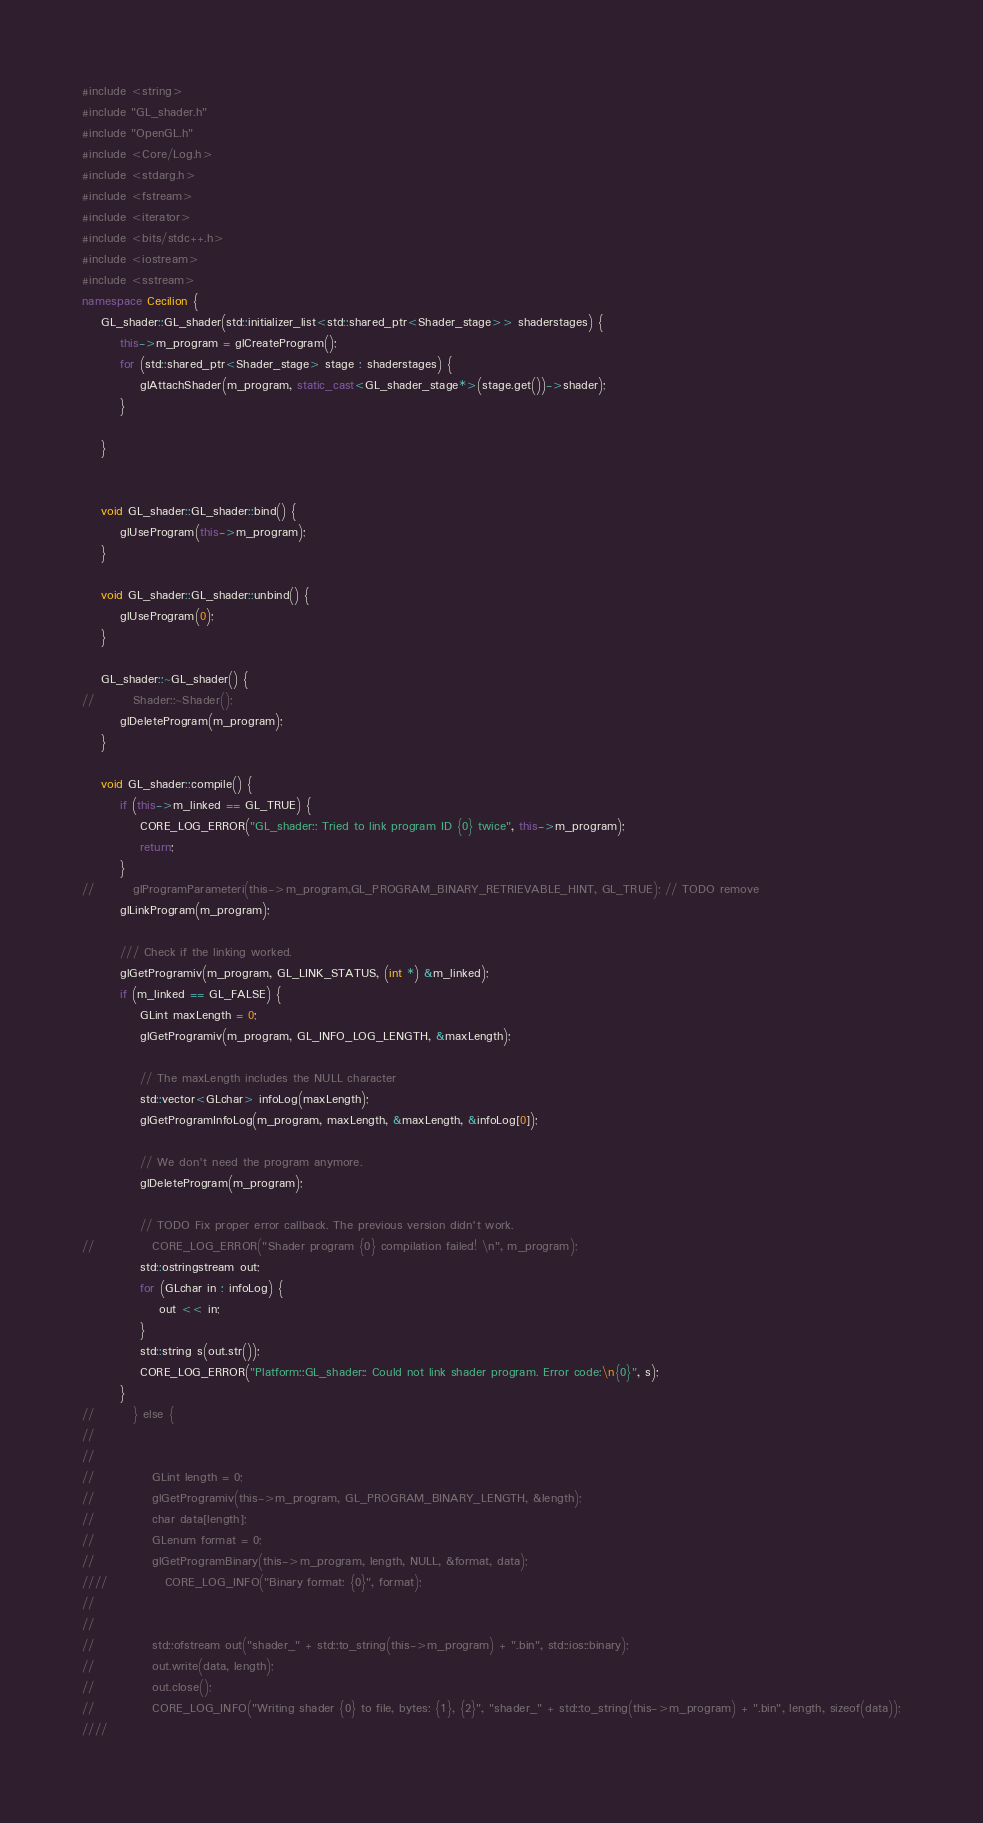<code> <loc_0><loc_0><loc_500><loc_500><_C++_>#include <string>
#include "GL_shader.h"
#include "OpenGL.h"
#include <Core/Log.h>
#include <stdarg.h>
#include <fstream>
#include <iterator>
#include <bits/stdc++.h>
#include <iostream>
#include <sstream>
namespace Cecilion {
    GL_shader::GL_shader(std::initializer_list<std::shared_ptr<Shader_stage>> shaderstages) {
        this->m_program = glCreateProgram();
        for (std::shared_ptr<Shader_stage> stage : shaderstages) {
            glAttachShader(m_program, static_cast<GL_shader_stage*>(stage.get())->shader);
        }

    }


    void GL_shader::GL_shader::bind() {
        glUseProgram(this->m_program);
    }

    void GL_shader::GL_shader::unbind() {
        glUseProgram(0);
    }

    GL_shader::~GL_shader() {
//        Shader::~Shader();
        glDeleteProgram(m_program);
    }

    void GL_shader::compile() {
        if (this->m_linked == GL_TRUE) {
            CORE_LOG_ERROR("GL_shader:: Tried to link program ID {0} twice", this->m_program);
            return;
        }
//        glProgramParameteri(this->m_program,GL_PROGRAM_BINARY_RETRIEVABLE_HINT, GL_TRUE); // TODO remove
        glLinkProgram(m_program);

        /// Check if the linking worked.
        glGetProgramiv(m_program, GL_LINK_STATUS, (int *) &m_linked);
        if (m_linked == GL_FALSE) {
            GLint maxLength = 0;
            glGetProgramiv(m_program, GL_INFO_LOG_LENGTH, &maxLength);

            // The maxLength includes the NULL character
            std::vector<GLchar> infoLog(maxLength);
            glGetProgramInfoLog(m_program, maxLength, &maxLength, &infoLog[0]);

            // We don't need the program anymore.
            glDeleteProgram(m_program);

            // TODO Fix proper error callback. The previous version didn't work.
//            CORE_LOG_ERROR("Shader program {0} compilation failed! \n", m_program);
            std::ostringstream out;
            for (GLchar in : infoLog) {
                out << in;
            }
            std::string s(out.str());
            CORE_LOG_ERROR("Platform::GL_shader:: Could not link shader program. Error code:\n{0}", s);
        }
//        } else {
//
//
//            GLint length = 0;
//            glGetProgramiv(this->m_program, GL_PROGRAM_BINARY_LENGTH, &length);
//            char data[length];
//            GLenum format = 0;
//            glGetProgramBinary(this->m_program, length, NULL, &format, data);
////            CORE_LOG_INFO("Binary format: {0}", format);
//
//
//            std::ofstream out("shader_" + std::to_string(this->m_program) + ".bin", std::ios::binary);
//            out.write(data, length);
//            out.close();
//            CORE_LOG_INFO("Writing shader {0} to file, bytes: {1}, {2}", "shader_" + std::to_string(this->m_program) + ".bin", length, sizeof(data));
////</code> 